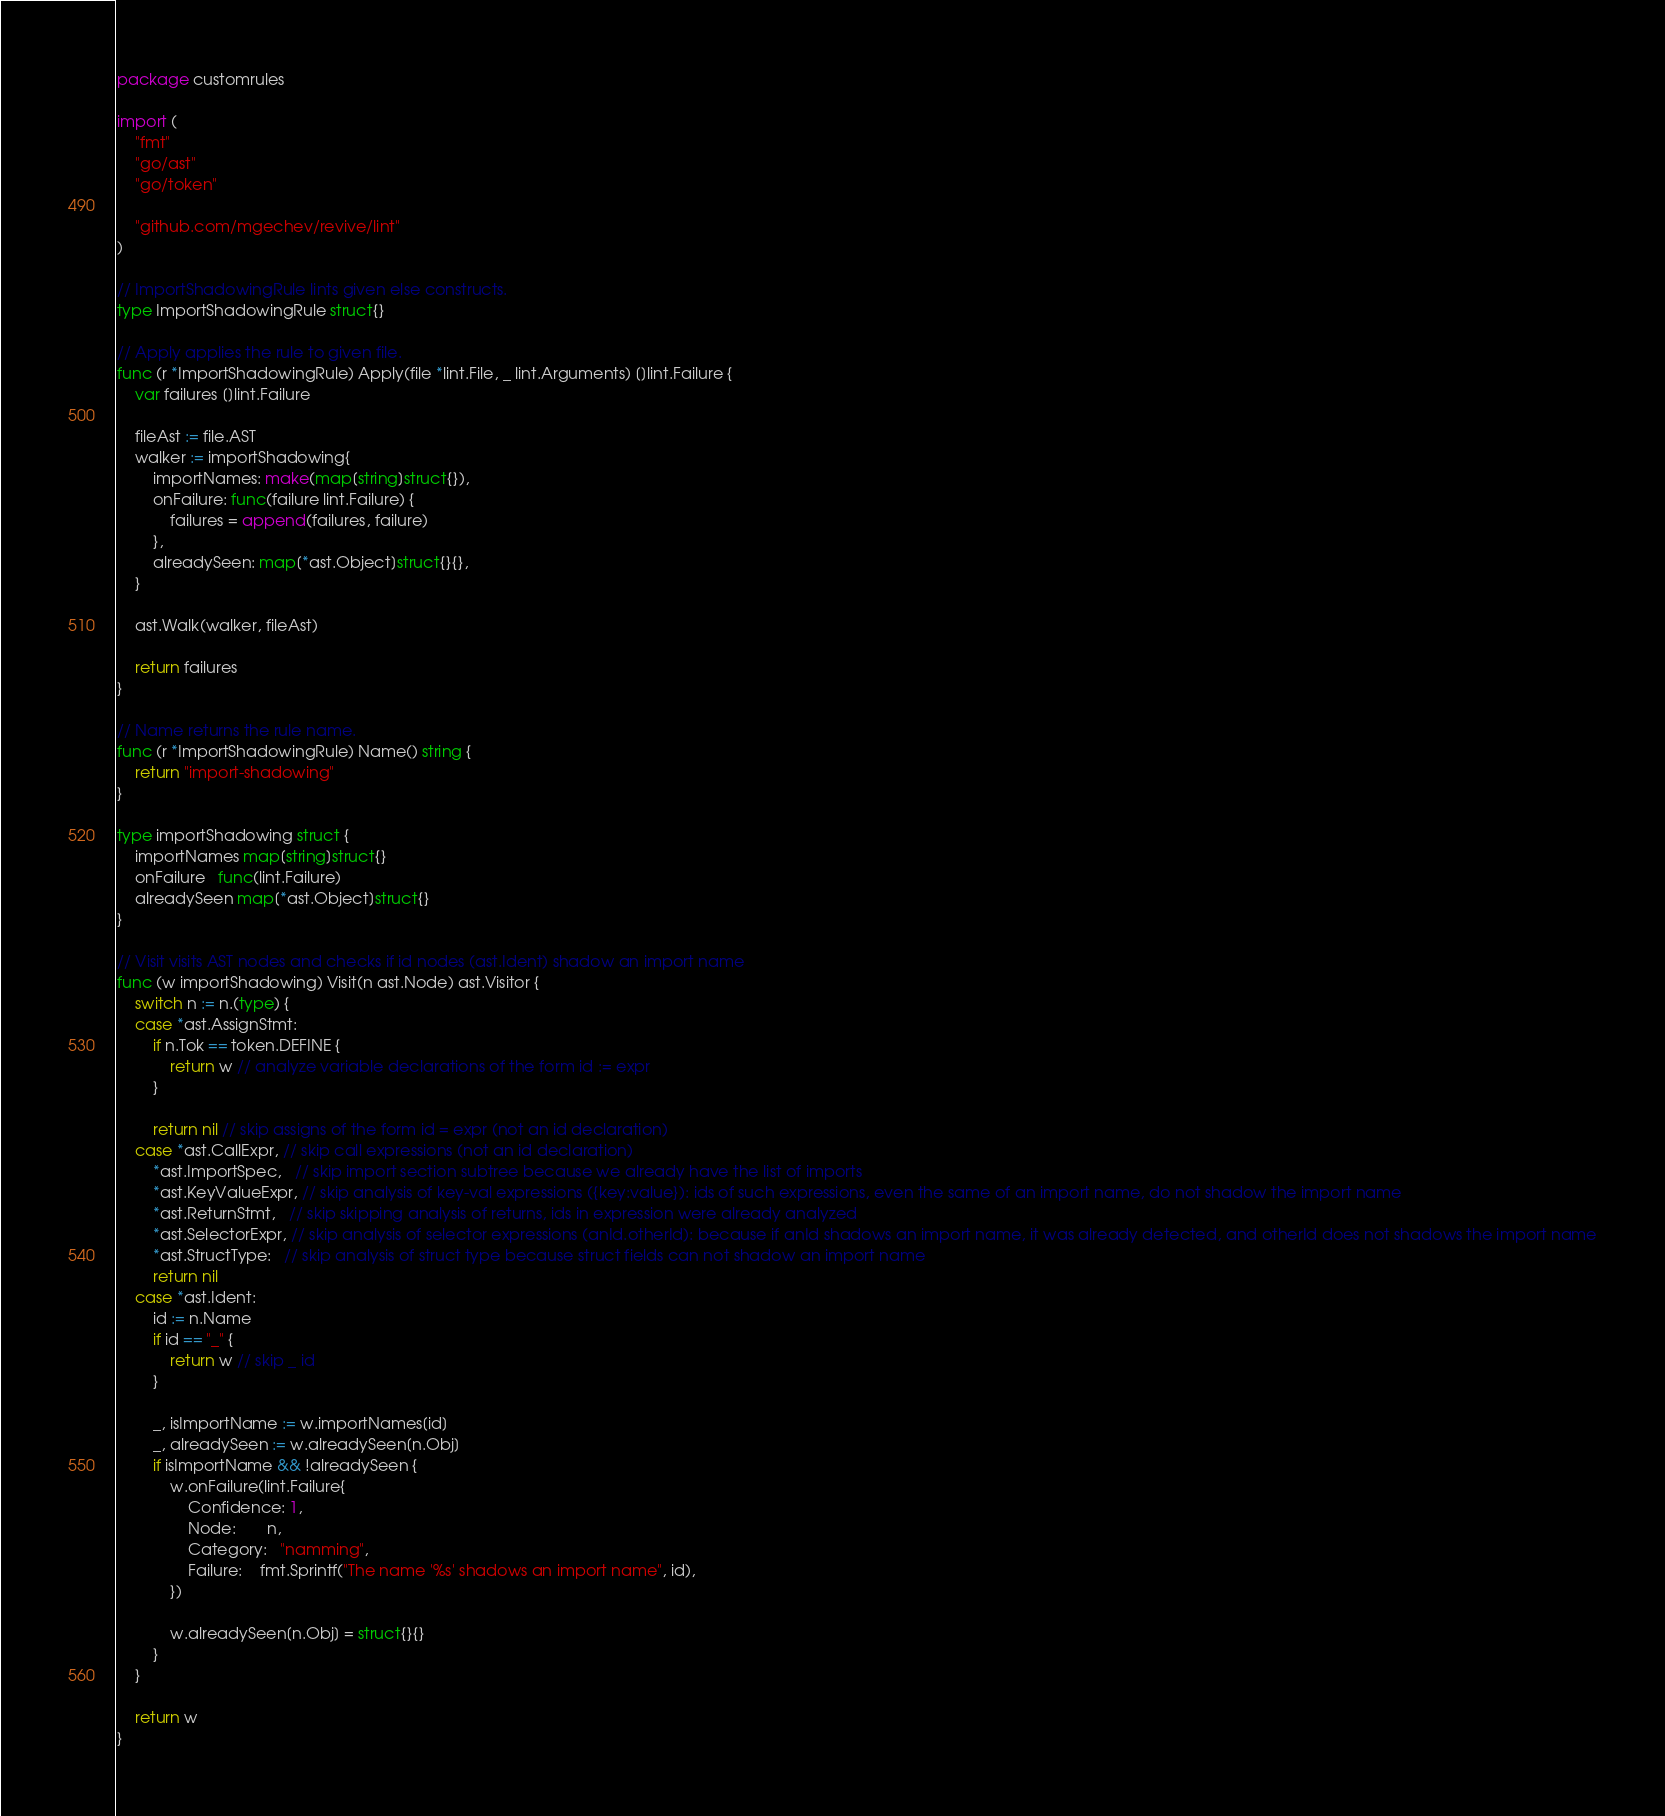Convert code to text. <code><loc_0><loc_0><loc_500><loc_500><_Go_>package customrules

import (
	"fmt"
	"go/ast"
	"go/token"

	"github.com/mgechev/revive/lint"
)

// ImportShadowingRule lints given else constructs.
type ImportShadowingRule struct{}

// Apply applies the rule to given file.
func (r *ImportShadowingRule) Apply(file *lint.File, _ lint.Arguments) []lint.Failure {
	var failures []lint.Failure

	fileAst := file.AST
	walker := importShadowing{
		importNames: make(map[string]struct{}),
		onFailure: func(failure lint.Failure) {
			failures = append(failures, failure)
		},
		alreadySeen: map[*ast.Object]struct{}{},
	}

	ast.Walk(walker, fileAst)

	return failures
}

// Name returns the rule name.
func (r *ImportShadowingRule) Name() string {
	return "import-shadowing"
}

type importShadowing struct {
	importNames map[string]struct{}
	onFailure   func(lint.Failure)
	alreadySeen map[*ast.Object]struct{}
}

// Visit visits AST nodes and checks if id nodes (ast.Ident) shadow an import name
func (w importShadowing) Visit(n ast.Node) ast.Visitor {
	switch n := n.(type) {
	case *ast.AssignStmt:
		if n.Tok == token.DEFINE {
			return w // analyze variable declarations of the form id := expr
		}

		return nil // skip assigns of the form id = expr (not an id declaration)
	case *ast.CallExpr, // skip call expressions (not an id declaration)
		*ast.ImportSpec,   // skip import section subtree because we already have the list of imports
		*ast.KeyValueExpr, // skip analysis of key-val expressions ({key:value}): ids of such expressions, even the same of an import name, do not shadow the import name
		*ast.ReturnStmt,   // skip skipping analysis of returns, ids in expression were already analyzed
		*ast.SelectorExpr, // skip analysis of selector expressions (anId.otherId): because if anId shadows an import name, it was already detected, and otherId does not shadows the import name
		*ast.StructType:   // skip analysis of struct type because struct fields can not shadow an import name
		return nil
	case *ast.Ident:
		id := n.Name
		if id == "_" {
			return w // skip _ id
		}

		_, isImportName := w.importNames[id]
		_, alreadySeen := w.alreadySeen[n.Obj]
		if isImportName && !alreadySeen {
			w.onFailure(lint.Failure{
				Confidence: 1,
				Node:       n,
				Category:   "namming",
				Failure:    fmt.Sprintf("The name '%s' shadows an import name", id),
			})

			w.alreadySeen[n.Obj] = struct{}{}
		}
	}

	return w
}
</code> 